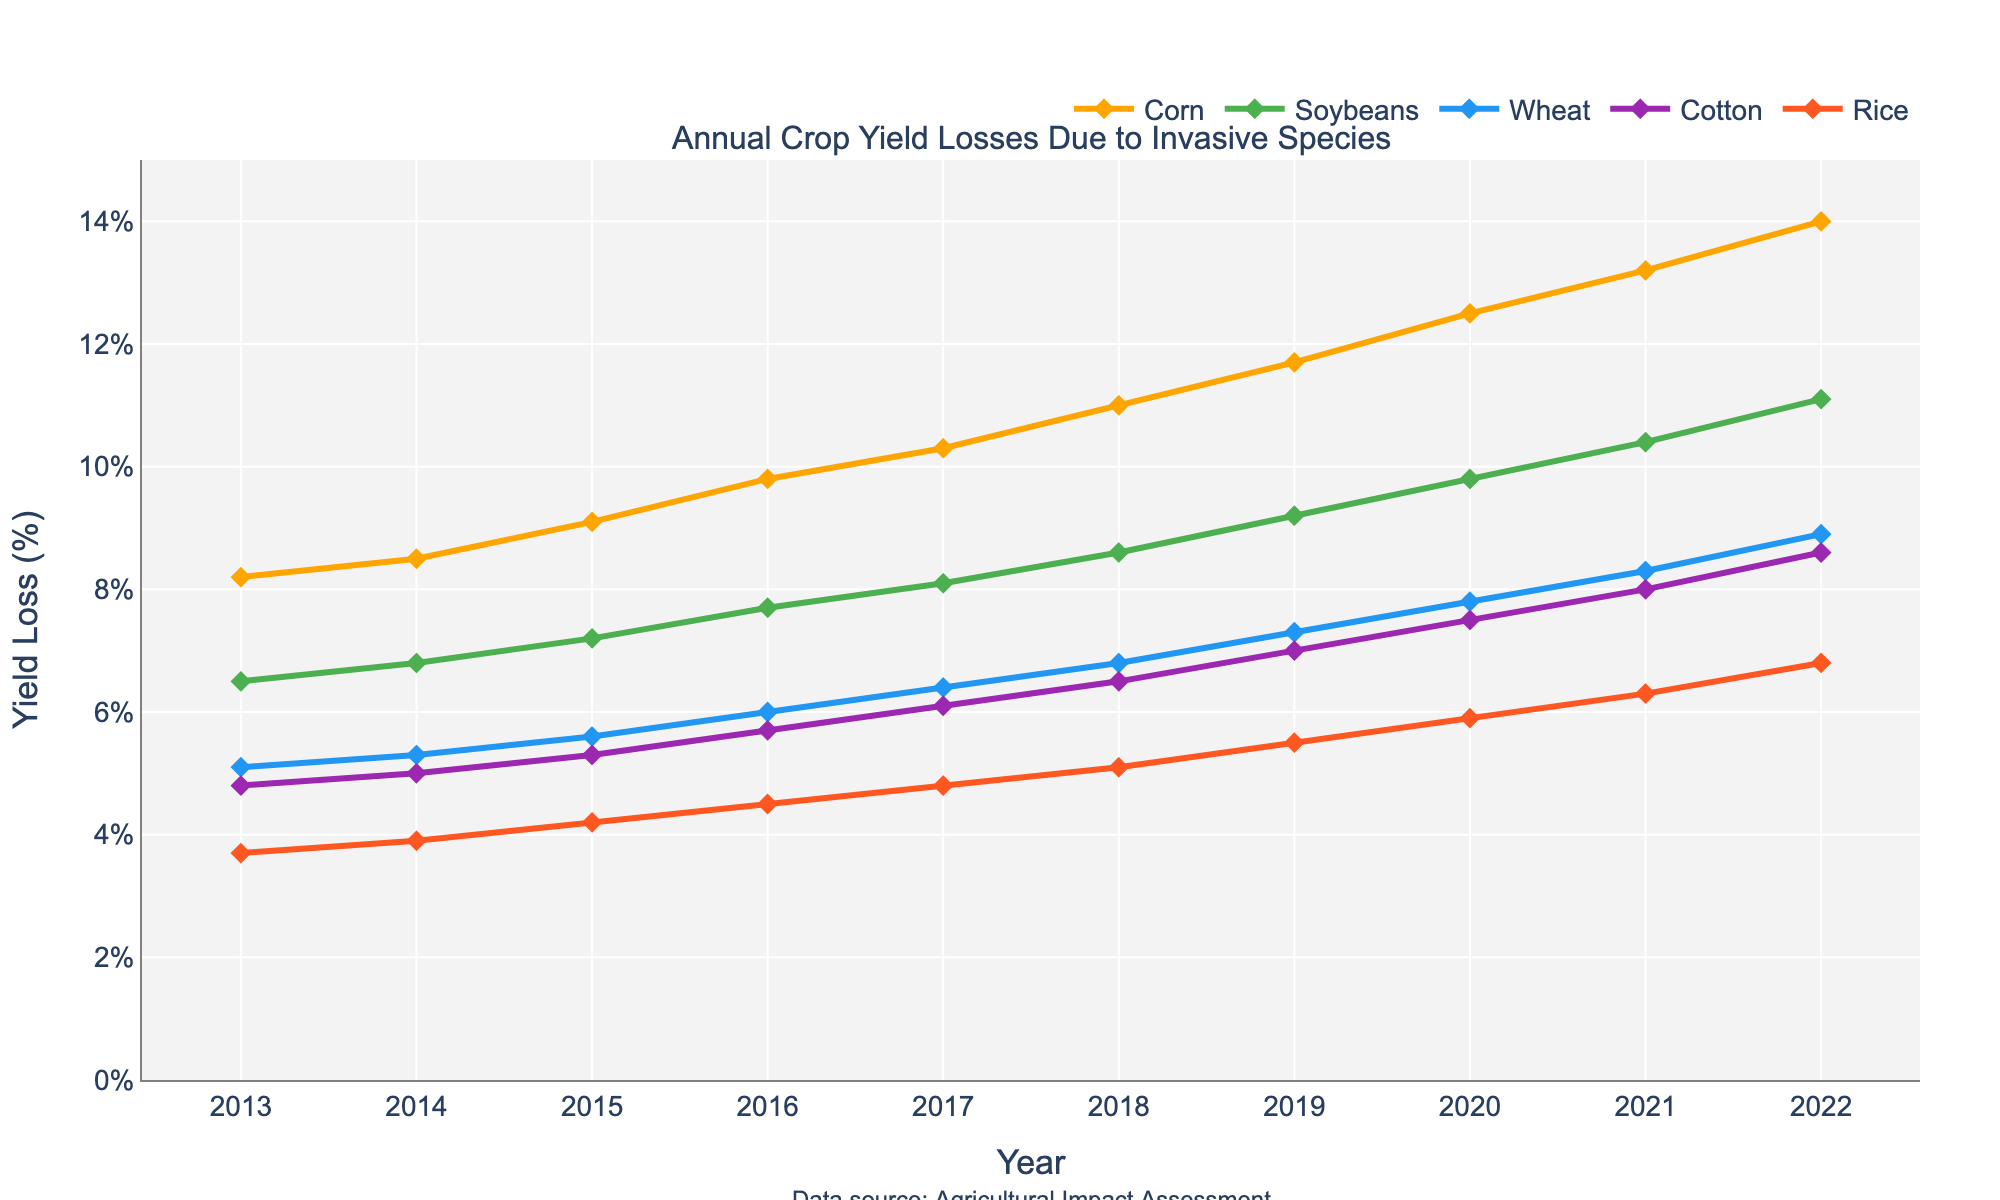What's the crop type with the highest yield loss in 2022? Look at the yield losses for each crop type in 2022 and identify the highest value. Corn has the highest yield loss at 14.0%.
Answer: Corn Among the crop types, which one had the smallest increase in yield loss from 2013 to 2022? Calculate the difference in yield loss from 2013 to 2022 for each crop type and find the smallest difference: Corn (14.0 - 8.2 = 5.8), Soybeans (11.1 - 6.5 = 4.6), Wheat (8.9 - 5.1 = 3.8), Cotton (8.6 - 4.8 = 3.8), Rice (6.8 - 3.7 = 3.1). Rice had the smallest increase.
Answer: Rice In what year did Soybeans surpass a yield loss of 8%? On the line for Soybeans, identify the first year where the yield loss is greater than 8%. In 2017, Soybeans' yield loss is 8.1%.
Answer: 2017 Between 2015 and 2018, which crop type had the largest absolute increase in yield loss? Calculate the yield loss change for each crop type from 2015 to 2018: Corn (11.0 - 9.1 = 1.9), Soybeans (8.6 - 7.2 = 1.4), Wheat (6.8 - 5.6 = 1.2), Cotton (6.5 - 5.3 = 1.2), Rice (5.1 - 4.2 = 0.9). Corn had the largest increase.
Answer: Corn What is the average annual yield loss for Wheat from 2013 to 2022? Sum the yield losses for Wheat from 2013 to 2022 and divide by the number of years: (5.1 + 5.3 + 5.6 + 6.0 + 6.4 + 6.8 + 7.3 + 7.8 + 8.3 + 8.9) / 10 = 67.5 / 10.
Answer: 6.75 Which year saw the largest single-year increase in yield loss for Cotton? Calculate the difference in yield loss for Cotton year-over-year and identify the largest: 2013-2014 (5.0 - 4.8 = 0.2), 2014-2015 (5.3 - 5.0 = 0.3), 2015-2016 (5.7 - 5.3 = 0.4), 2016-2017 (6.1 - 5.7 = 0.4), 2017-2018 (6.5 - 6.1 = 0.4), 2018-2019 (7.0 - 6.5 = 0.5), 2019-2020 (7.5 - 7.0 = 0.5), 2020-2021 (8.0 - 7.5 = 0.5), 2021-2022 (8.6 - 8.0 = 0.6). 2021-2022 had the largest increase with 0.6.
Answer: 2021-2022 Which crop type had the most consistent increase in yield loss over the decade? Observing the lines for each crop type, Corn shows a steady and consistent increase from 8.2% in 2013 to 14.0% in 2022.
Answer: Corn 